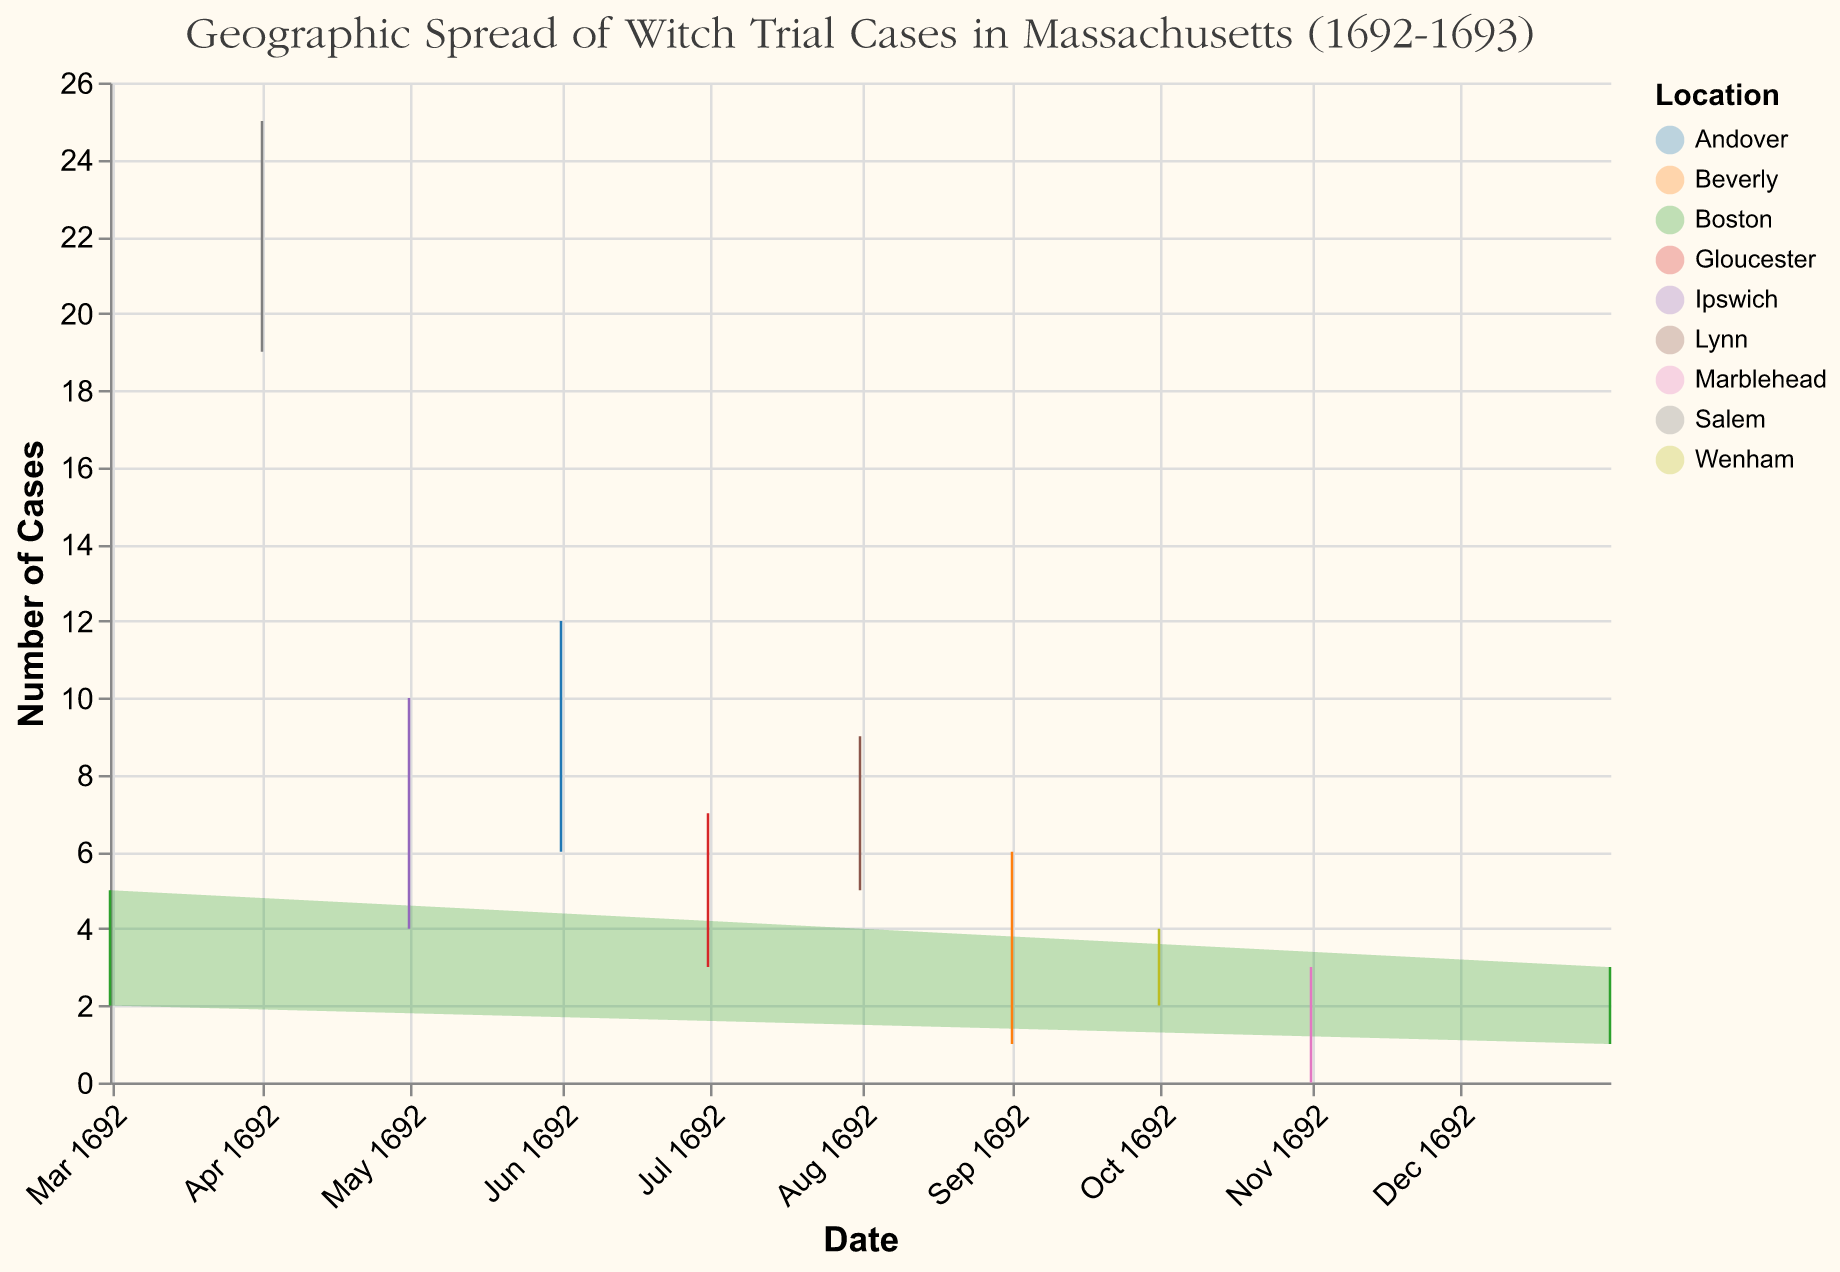What is the title of the chart? The title of the chart can be found at the top of the figure and it reads: "Geographic Spread of Witch Trial Cases in Massachusetts (1692-1693)."
Answer: Geographic Spread of Witch Trial Cases in Massachusetts (1692-1693) Which location had the highest maximum number of witch trial cases? By examining the highest points in the chart, the location with the highest maximum number of witch trial cases is Salem, which had a maximum of 25 cases in April 1692.
Answer: Salem How many locations are depicted in the chart? Each color represents a different location, and the legend indicates multiple distinct colors. Counting these unique entries gives the total number of locations. There are 10 different locations depicted in the chart.
Answer: 10 What pattern or trend can be observed in the number of cases in Boston from 1692 to 1693? Looking at the data points for Boston, you see two time periods represented: March 1692 and January 1693. The minimum and maximum number of cases in March 1692 ranges between 2 and 5. There is a decrease in both the minimum and maximum number of cases by January 1693, ranging from 1 to 3. This shows that the number of cases in Boston decreased over time.
Answer: Decrease When did Andover see the highest number of cases? Find the data point corresponding to Andover and note the time and height of the area. Andover's highest number of cases (12) occurred in June 1692.
Answer: June 1692 Which month had the highest range in the number of cases in Salem? To determine the range, subtract the minimum cases from the maximum cases for each month in Salem. In April 1692, the range is 25 - 19 = 6, which is the highest for Salem.
Answer: April 1692 Compare the number of cases in Ipswich and Gloucester in May and July respectively. Which location had more maximum cases? Check the maximum cases for Ipswich in May (10) and for Gloucester in July (7). Ipswich had more maximum cases with a count of 10 in May.
Answer: Ipswich What's the total minimum number of cases reported across all locations in September 1692? Only Beverly has reported minimum cases for September 1692, which is 1.
Answer: 1 During which month did Marblehead report its range of cases, and what was the range? Locate Marblehead in the chart and note the range where the shaded area appears. Marblehead's cases are shown for November 1692, with a maximum of 3 and a minimum of 0. The range is 3 - 0 = 3.
Answer: November 1692 and Range is 3 What is the average maximum number of cases reported in Salem across all months in 1692? To find the average, take the maximum number of cases for each available month for Salem and find their arithmetic mean. The maximum cases are recorded for only one month, April 1692, with 25 cases. Therefore, the average remains 25 since there is only one data point.
Answer: 25 